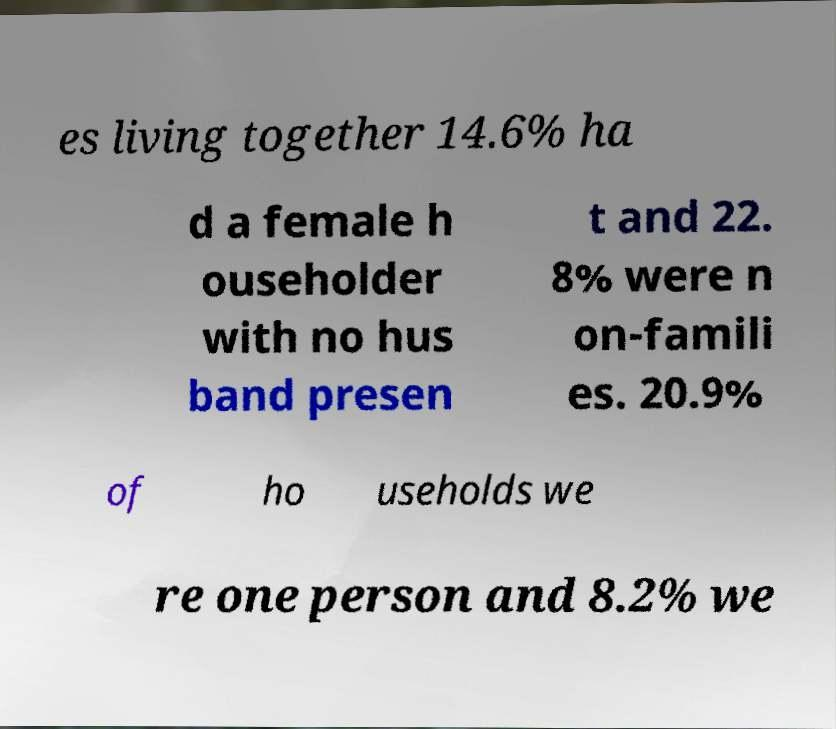For documentation purposes, I need the text within this image transcribed. Could you provide that? es living together 14.6% ha d a female h ouseholder with no hus band presen t and 22. 8% were n on-famili es. 20.9% of ho useholds we re one person and 8.2% we 